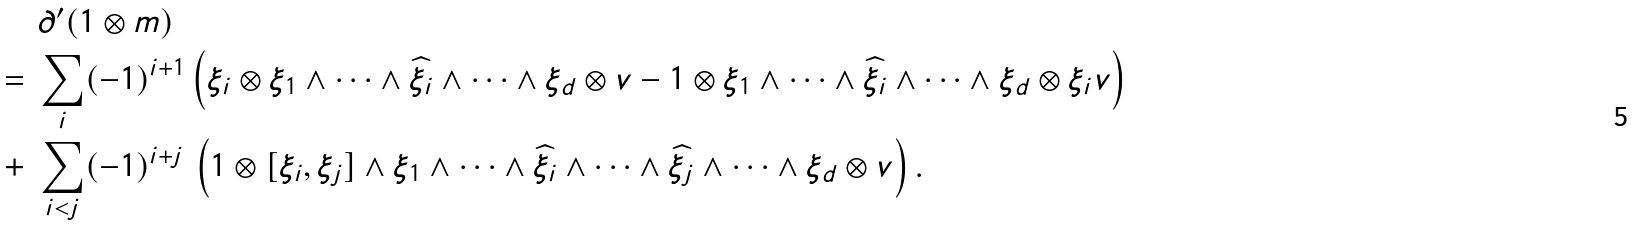Convert formula to latex. <formula><loc_0><loc_0><loc_500><loc_500>& \partial ^ { \prime } ( 1 \otimes m ) \\ = \ & \sum _ { i } ( - 1 ) ^ { i + 1 } \left ( \xi _ { i } \otimes \xi _ { 1 } \wedge \cdots \wedge \widehat { \xi _ { i } } \wedge \cdots \wedge \xi _ { d } \otimes v - 1 \otimes \xi _ { 1 } \wedge \cdots \wedge \widehat { \xi _ { i } } \wedge \cdots \wedge \xi _ { d } \otimes \xi _ { i } v \right ) \\ + \ & \sum _ { i < j } ( - 1 ) ^ { i + j } \, \left ( 1 \otimes [ \xi _ { i } , \xi _ { j } ] \wedge \xi _ { 1 } \wedge \cdots \wedge \widehat { \xi _ { i } } \wedge \cdots \wedge \widehat { \xi _ { j } } \wedge \cdots \wedge \xi _ { d } \otimes v \right ) .</formula> 